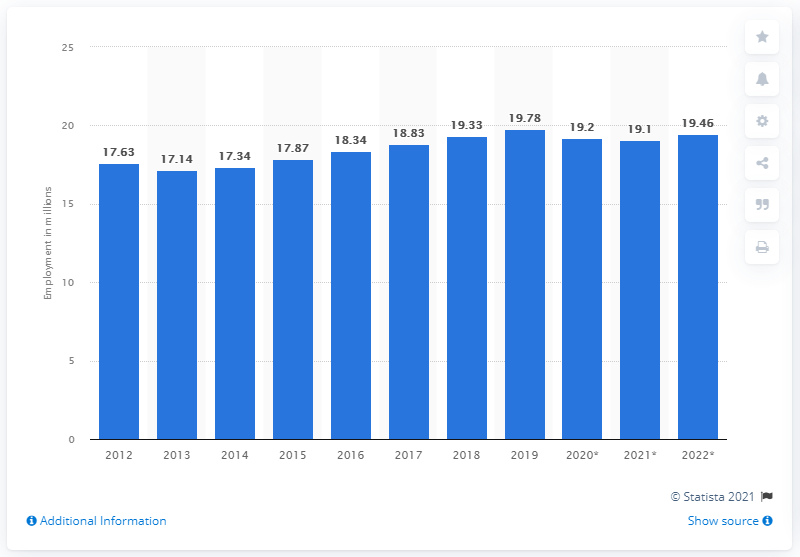Outline some significant characteristics in this image. In 2019, 19.78 people were employed in Spain. In 2012, the level of employment in Spain was measured. 